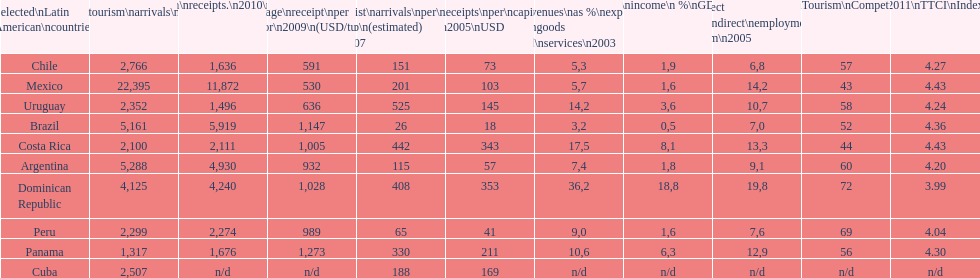Tourism income in latin american countries in 2003 was at most what percentage of gdp? 18,8. 